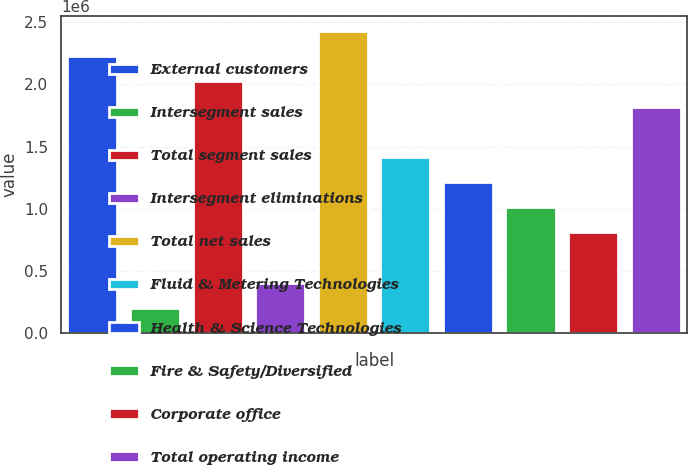Convert chart. <chart><loc_0><loc_0><loc_500><loc_500><bar_chart><fcel>External customers<fcel>Intersegment sales<fcel>Total segment sales<fcel>Intersegment eliminations<fcel>Total net sales<fcel>Fluid & Metering Technologies<fcel>Health & Science Technologies<fcel>Fire & Safety/Diversified<fcel>Corporate office<fcel>Total operating income<nl><fcel>2.22653e+06<fcel>202573<fcel>2.02413e+06<fcel>404968<fcel>2.42892e+06<fcel>1.41694e+06<fcel>1.21455e+06<fcel>1.01215e+06<fcel>809759<fcel>1.82173e+06<nl></chart> 